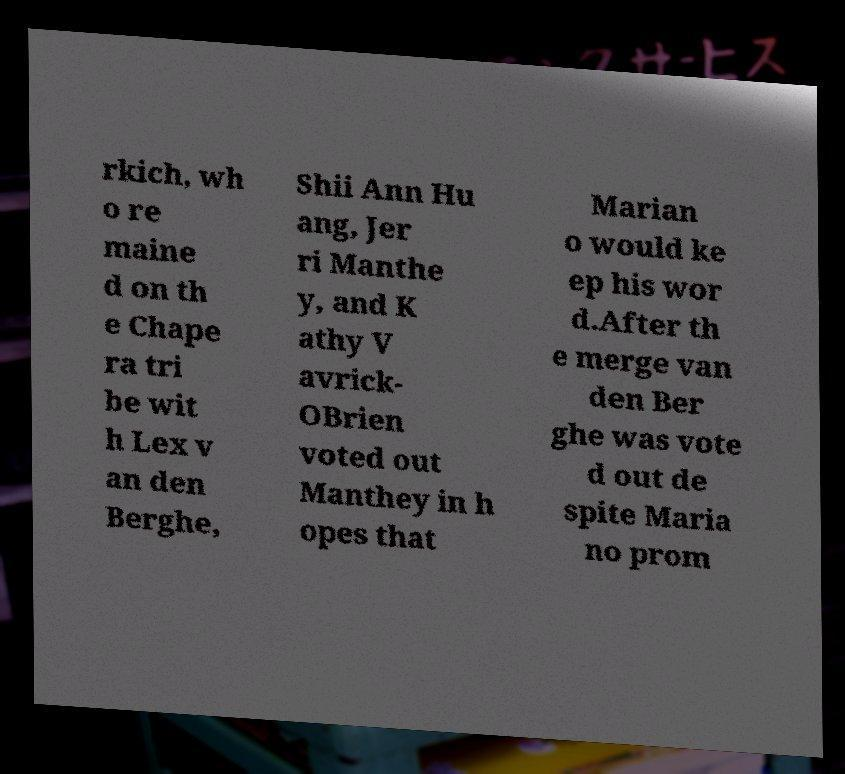For documentation purposes, I need the text within this image transcribed. Could you provide that? rkich, wh o re maine d on th e Chape ra tri be wit h Lex v an den Berghe, Shii Ann Hu ang, Jer ri Manthe y, and K athy V avrick- OBrien voted out Manthey in h opes that Marian o would ke ep his wor d.After th e merge van den Ber ghe was vote d out de spite Maria no prom 